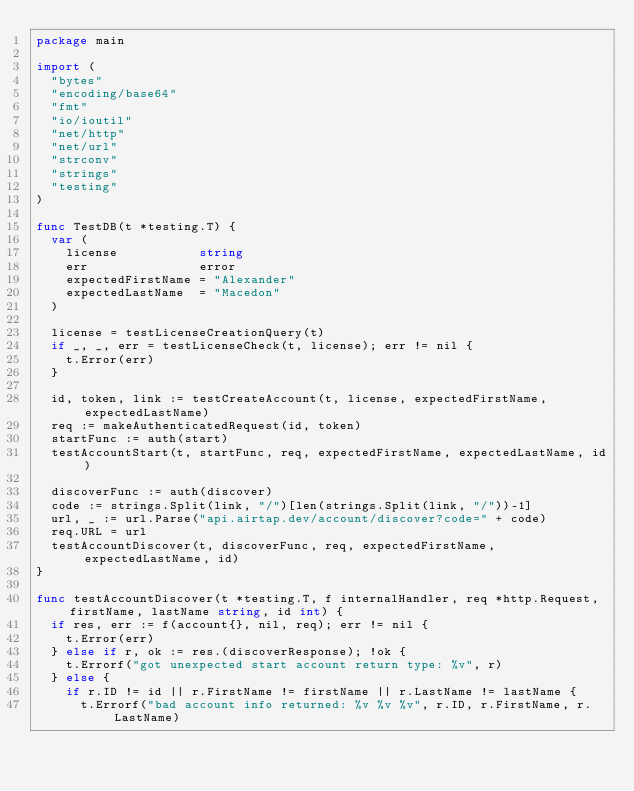Convert code to text. <code><loc_0><loc_0><loc_500><loc_500><_Go_>package main

import (
	"bytes"
	"encoding/base64"
	"fmt"
	"io/ioutil"
	"net/http"
	"net/url"
	"strconv"
	"strings"
	"testing"
)

func TestDB(t *testing.T) {
	var (
		license           string
		err               error
		expectedFirstName = "Alexander"
		expectedLastName  = "Macedon"
	)

	license = testLicenseCreationQuery(t)
	if _, _, err = testLicenseCheck(t, license); err != nil {
		t.Error(err)
	}

	id, token, link := testCreateAccount(t, license, expectedFirstName, expectedLastName)
	req := makeAuthenticatedRequest(id, token)
	startFunc := auth(start)
	testAccountStart(t, startFunc, req, expectedFirstName, expectedLastName, id)

	discoverFunc := auth(discover)
	code := strings.Split(link, "/")[len(strings.Split(link, "/"))-1]
	url, _ := url.Parse("api.airtap.dev/account/discover?code=" + code)
	req.URL = url
	testAccountDiscover(t, discoverFunc, req, expectedFirstName, expectedLastName, id)
}

func testAccountDiscover(t *testing.T, f internalHandler, req *http.Request, firstName, lastName string, id int) {
	if res, err := f(account{}, nil, req); err != nil {
		t.Error(err)
	} else if r, ok := res.(discoverResponse); !ok {
		t.Errorf("got unexpected start account return type: %v", r)
	} else {
		if r.ID != id || r.FirstName != firstName || r.LastName != lastName {
			t.Errorf("bad account info returned: %v %v %v", r.ID, r.FirstName, r.LastName)</code> 